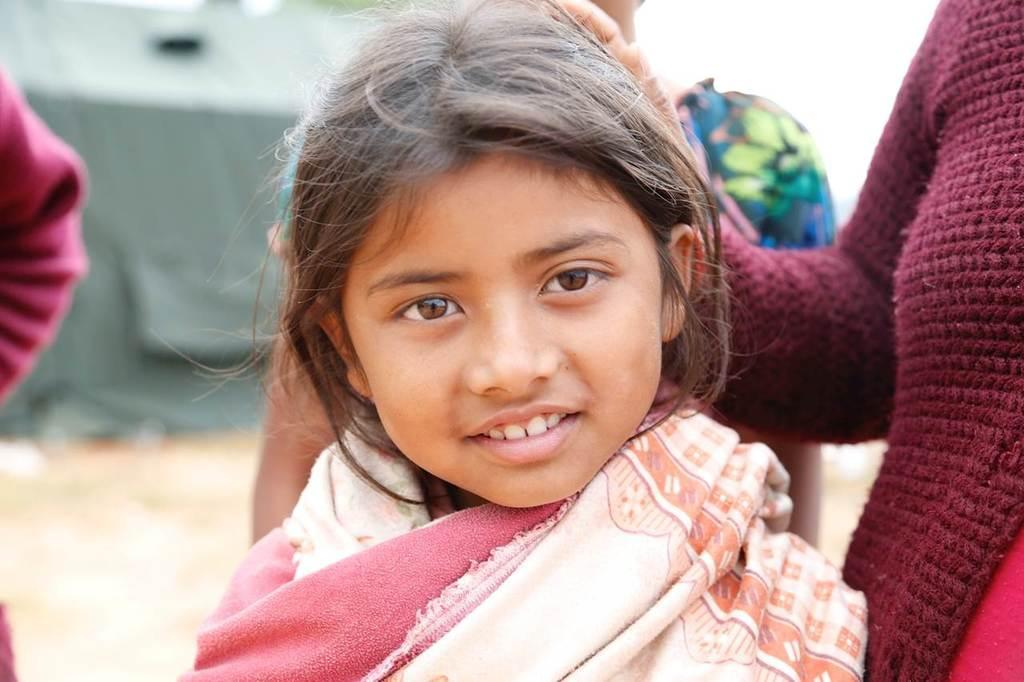Who is the main subject in the image? There is a girl in the center of the image. Are there any other people in the image? Yes, there are other persons beside the girl. What can be seen in the background of the image? There is a tent in the background of the image. What type of terrain is visible at the bottom of the image? There is sand visible at the bottom of the image. What type of oil can be seen dripping from the girl's hair in the image? There is no oil visible in the image, nor is it dripping from the girl's hair. 